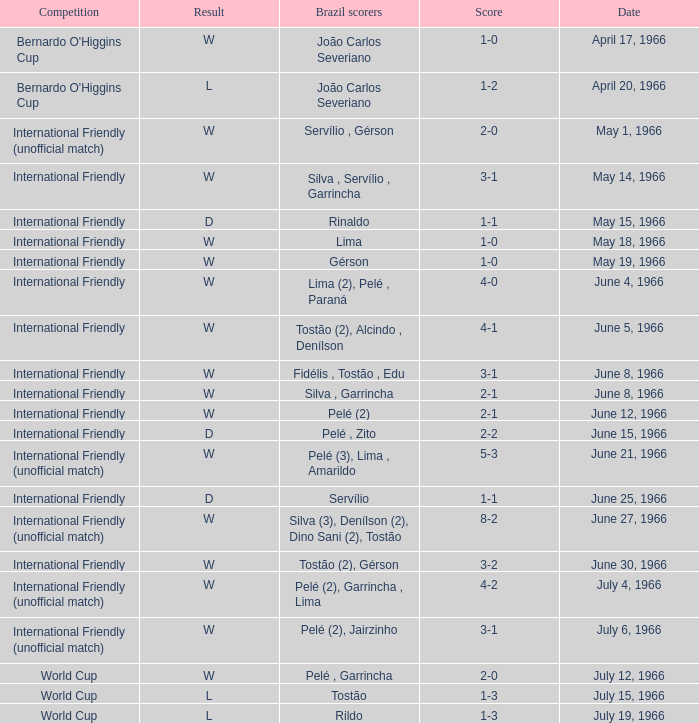What is the result when the score is 4-0? W. 